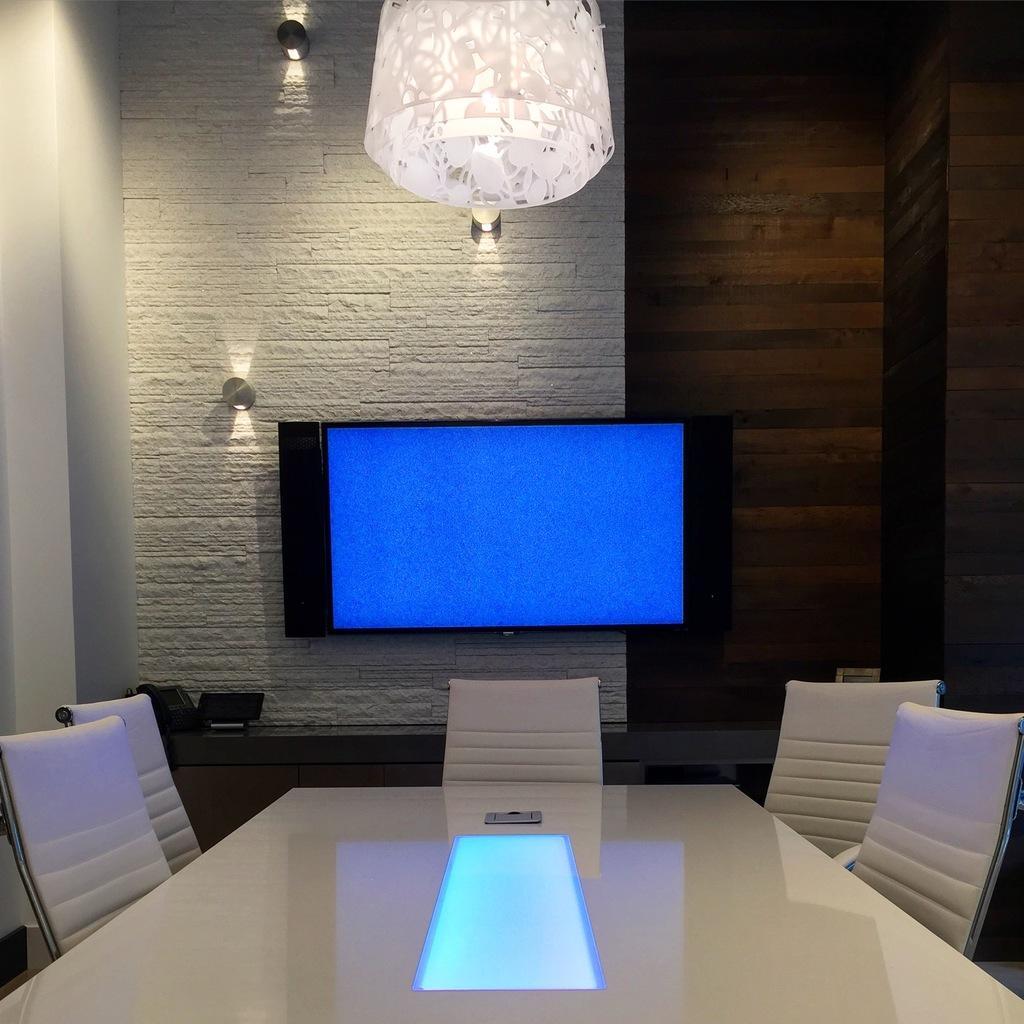Can you describe this image briefly? In this image, we can see a wall with lights. Here there is a television with speakers. At the bottom, we can see a desk with white chairs. Here we can see some objects. Right side of the image, we can see a wall. Top of the image, we can see a chandelier. 